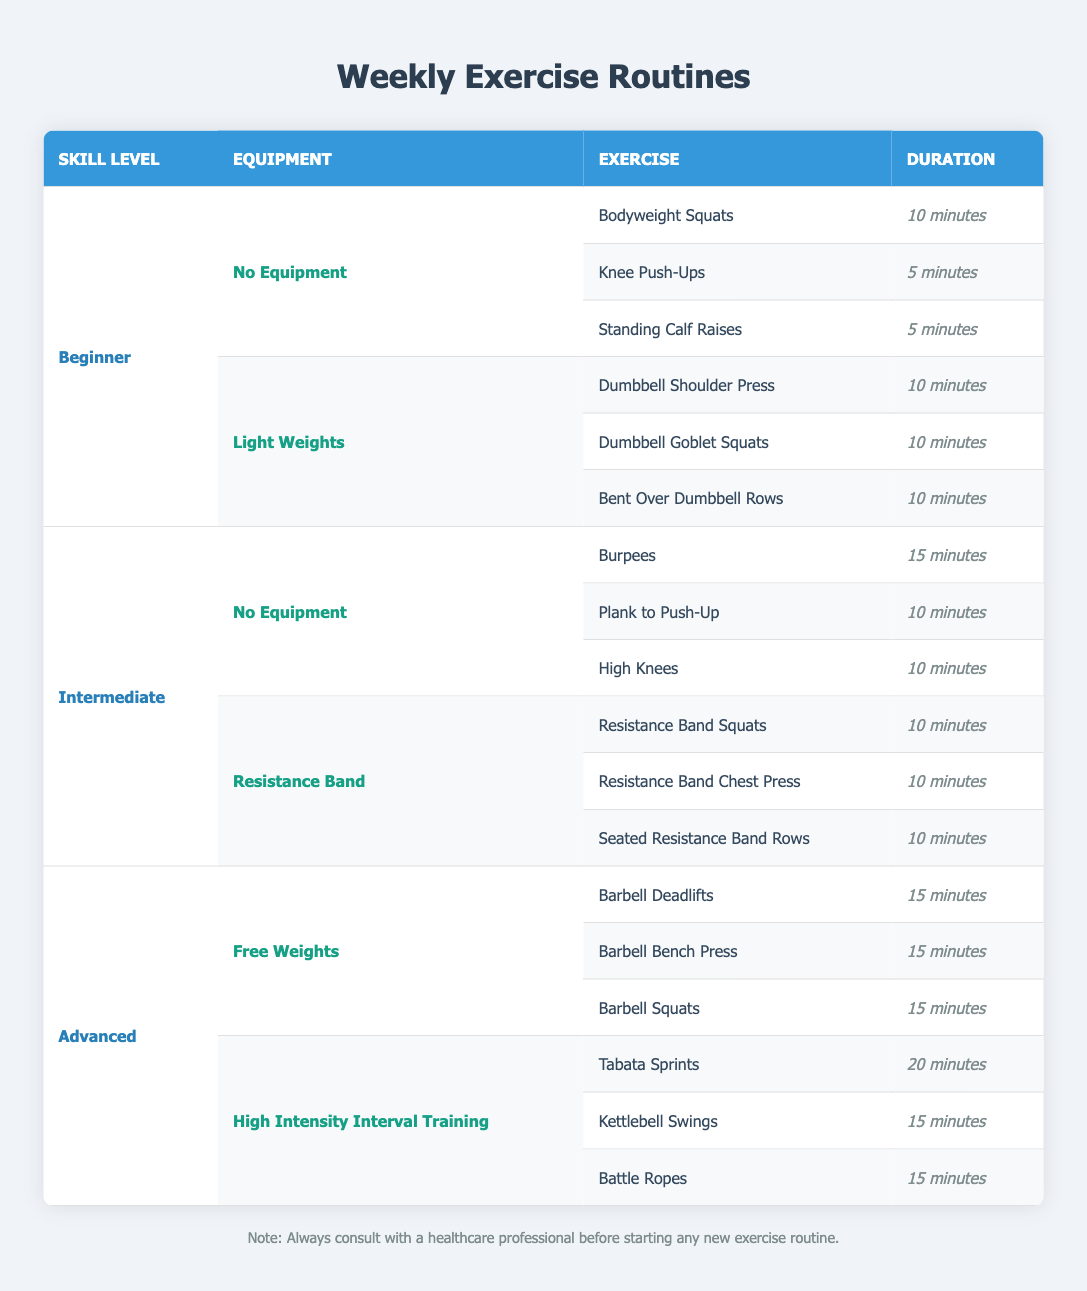What exercises are listed for the Beginner level with No Equipment? The table shows three exercises under the Beginner level with No Equipment: Bodyweight Squats (10 minutes), Knee Push-Ups (5 minutes), and Standing Calf Raises (5 minutes).
Answer: Bodyweight Squats, Knee Push-Ups, Standing Calf Raises How many minutes are allocated in total for exercises under the Intermediate level with Resistance Bands? There are three exercises listed under the Intermediate level with Resistance Bands: Resistance Band Squats (10 minutes), Resistance Band Chest Press (10 minutes), and Seated Resistance Band Rows (10 minutes). The total duration is 10 + 10 + 10 = 30 minutes.
Answer: 30 minutes Is there an exercise listed for the Intermediate level with No Equipment that lasts longer than 15 minutes? The exercises under the Intermediate level with No Equipment are Burpees (15 minutes), Plank to Push-Up (10 minutes), and High Knees (10 minutes). None of them exceed 15 minutes.
Answer: No What is the average duration of exercises in the Advanced level categories? In the Advanced level, there are two categories: Free Weights (3 exercises at 15 minutes each) and High Intensity Interval Training (3 exercises: Tabata Sprints (20 minutes), Kettlebell Swings (15 minutes), and Battle Ropes (15 minutes)). The total duration for Free Weights is 15 + 15 + 15 = 45 minutes and for High Intensity Interval Training is 20 + 15 + 15 = 50 minutes. Adding both totals gives 45 + 50 = 95 minutes for 6 exercises, so the average is 95/6 = approximately 15.83 minutes.
Answer: Approximately 15.83 minutes How many exercises do the Advanced level exercises contain that require Free Weights? The table indicates there are three exercises under the Advanced level that use Free Weights: Barbell Deadlifts, Barbell Bench Press, and Barbell Squats.
Answer: 3 